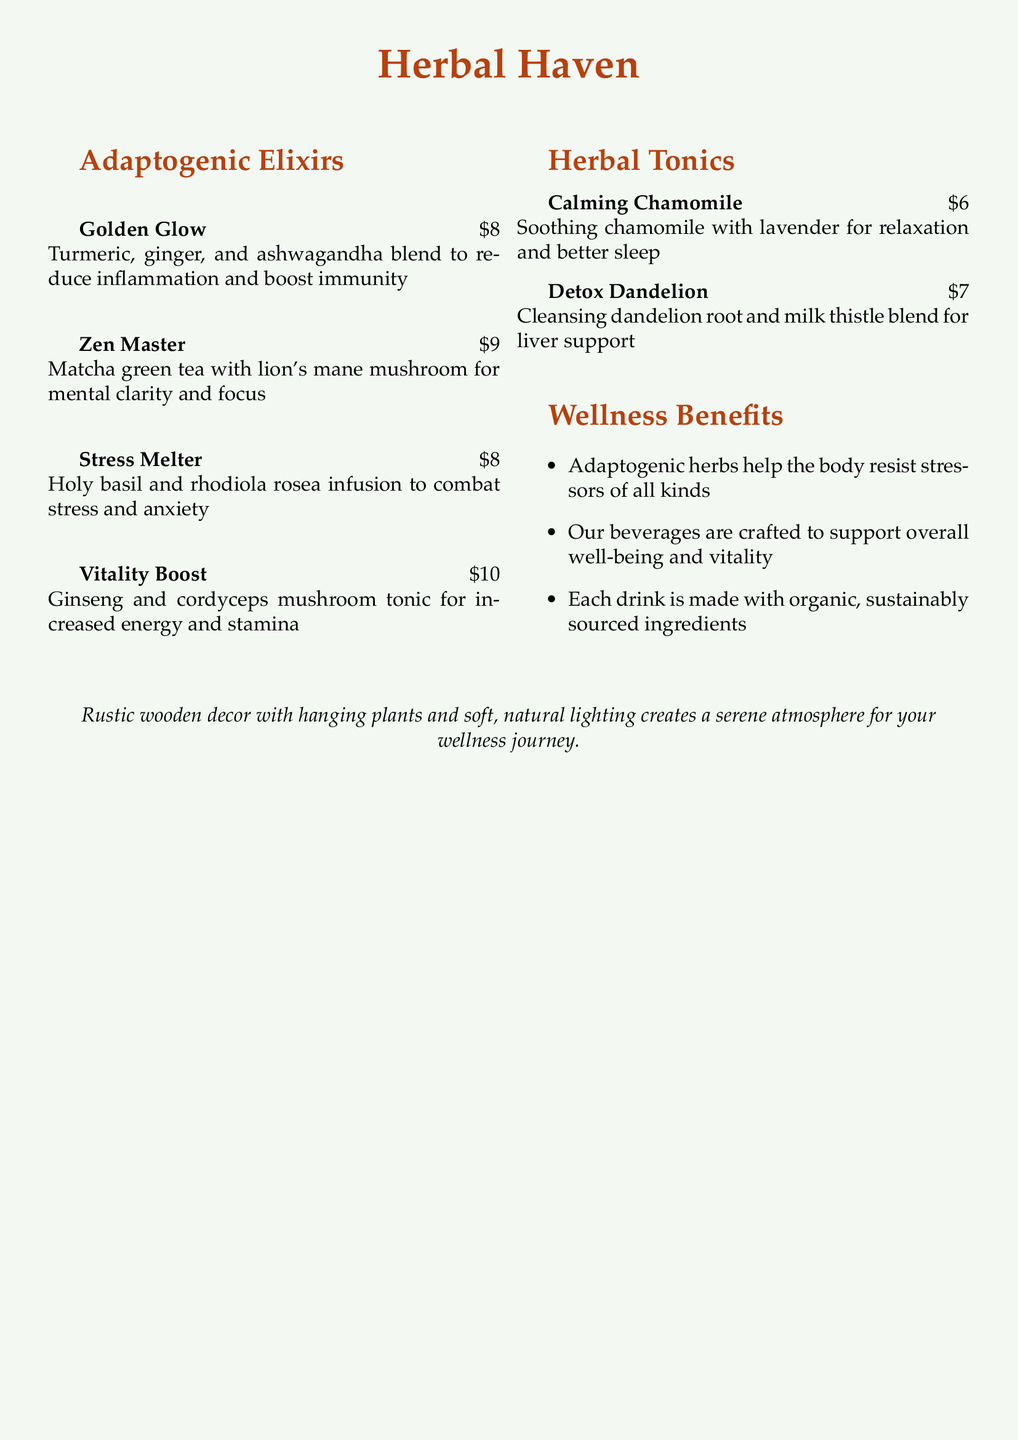What is the price of the Golden Glow drink? The price is indicated next to the drink name in the menu. The Golden Glow drink costs $8.
Answer: $8 What ingredients are in the Zen Master? The ingredients are listed under the drink name in the menu. It includes matcha green tea and lion's mane mushroom.
Answer: Matcha green tea and lion's mane mushroom What wellness benefit do adaptogenic herbs provide? The benefits of adaptogenic herbs are summarized in the "Wellness Benefits" section of the document. They help the body resist stressors.
Answer: Resist stressors How much does the Stress Melter cost? The cost of the Stress Melter is mentioned next to its name on the menu. It is priced at $8.
Answer: $8 Which drink is designed for relaxation and better sleep? The drink aimed at relaxation is specified in the menu. It is Calming Chamomile.
Answer: Calming Chamomile What is the herbal tonic that supports liver health? The herbal tonic that supports liver health is found in the "Herbal Tonics" section. It is Detox Dandelion.
Answer: Detox Dandelion How many different adaptogenic elixirs are listed? The count of adaptogenic elixirs can be determined by counting the entries in that section. There are four elixirs.
Answer: Four What is one of the benefits of the Vitality Boost? The benefits of the Vitality Boost can be inferred from the description in the menu. It increases energy.
Answer: Increases energy What color is the background of the document? The background color can be observed in the overall presentation of the document. It is a light sage color.
Answer: Light sage 